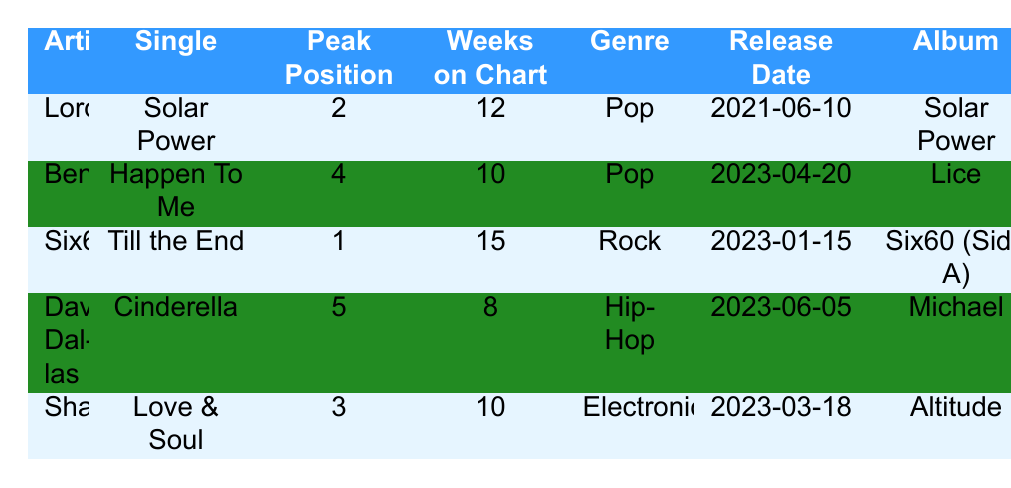What is the peak chart position of Six60's single "Till the End"? The table lists "Till the End" by Six60 with a peak chart position of 1.
Answer: 1 How many weeks has Benee's single "Happen To Me" been on the chart? The table indicates that "Happen To Me" has been on the chart for 10 weeks.
Answer: 10 Which artist achieved the highest total streams in 2023? Comparing the total streams of all artists in the table, Six60 has the highest with 2,500,000 streams.
Answer: Six60 Is Lorde's single "Solar Power" a Pop song? The genre listed for "Solar Power" by Lorde is Pop, confirming it is indeed a Pop song.
Answer: Yes What is the average number of fan interactions for the artists in the table? First, sum up the fan interactions: 50,000 + 40,000 + 60,000 + 25,000 + 30,000 = 205,000. There are 5 artists, so the average is 205,000 / 5 = 41,000.
Answer: 41,000 Which single spent more weeks on the chart, "Love & Soul" or "Cinderella"? "Love & Soul" by Shapeshifter spent 10 weeks on the chart, while "Cinderella" by David Dallas spent only 8 weeks, so "Love & Soul" spent more weeks.
Answer: "Love & Soul" How many total streams do Lorde and Benee have combined? Adding their total streams: 1,500,000 (Lorde) + 1,200,000 (Benee) = 2,700,000 total streams.
Answer: 2,700,000 Can you name an artist whose peak chart position is higher than 3? Looking at the table, both Six60 (peak position 1) and Lorde (peak position 2) have positions higher than 3.
Answer: Yes (Six60, Lorde) Which genre has the most artists represented in the table? Pop has two representatives (Lorde and Benee), while Rock (Six60), Hip-Hop (David Dallas), and Electronic (Shapeshifter) each have one; therefore, Pop is the most represented genre.
Answer: Pop What is the difference in total streams between Six60 and David Dallas? Six60 has 2,500,000 streams while David Dallas has 800,000 streams. The difference is 2,500,000 - 800,000 = 1,700,000.
Answer: 1,700,000 